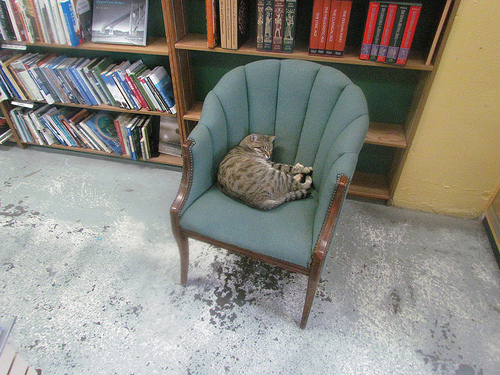<image>
Is the cat on the chair? Yes. Looking at the image, I can see the cat is positioned on top of the chair, with the chair providing support. Where is the cat in relation to the chair? Is it next to the chair? No. The cat is not positioned next to the chair. They are located in different areas of the scene. Where is the cat in relation to the bookshelves? Is it in front of the bookshelves? Yes. The cat is positioned in front of the bookshelves, appearing closer to the camera viewpoint. 